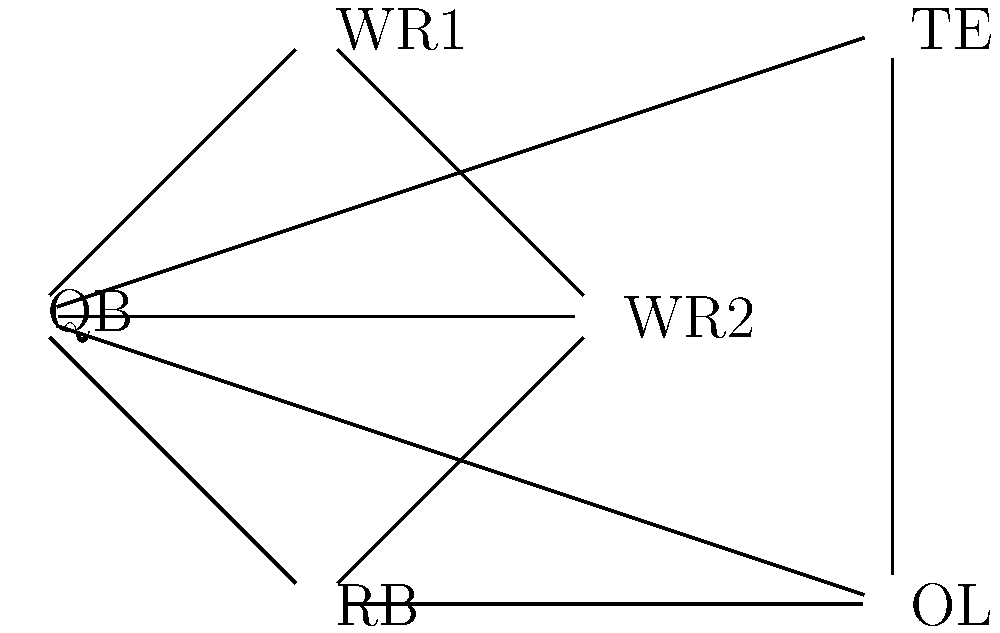In the given network topology for a football team's communication system, what is the minimum number of edges that need to be removed to disconnect the quarterback (QB) from all other positions? To solve this problem, we need to analyze the network topology and find the minimum cut set that separates the QB from all other nodes. Let's approach this step-by-step:

1. Identify the QB node: The QB is at the center of the network, connected to all other nodes.

2. Count the direct connections from QB:
   - QB is directly connected to WR1, WR2, RB, TE, and OL.
   - There are 5 direct connections from QB.

3. Check for alternative paths:
   - There are no alternative paths that don't go through the QB.
   - All other connections between positions go through at least one other node.

4. Determine the minimum cut:
   - To disconnect the QB from all other positions, we need to remove all edges connected to the QB.
   - There are no other paths that would keep the QB connected if we remove these edges.

5. Count the edges in the minimum cut:
   - The minimum cut consists of the 5 edges directly connected to the QB.

Therefore, the minimum number of edges that need to be removed to disconnect the QB from all other positions is 5.
Answer: 5 